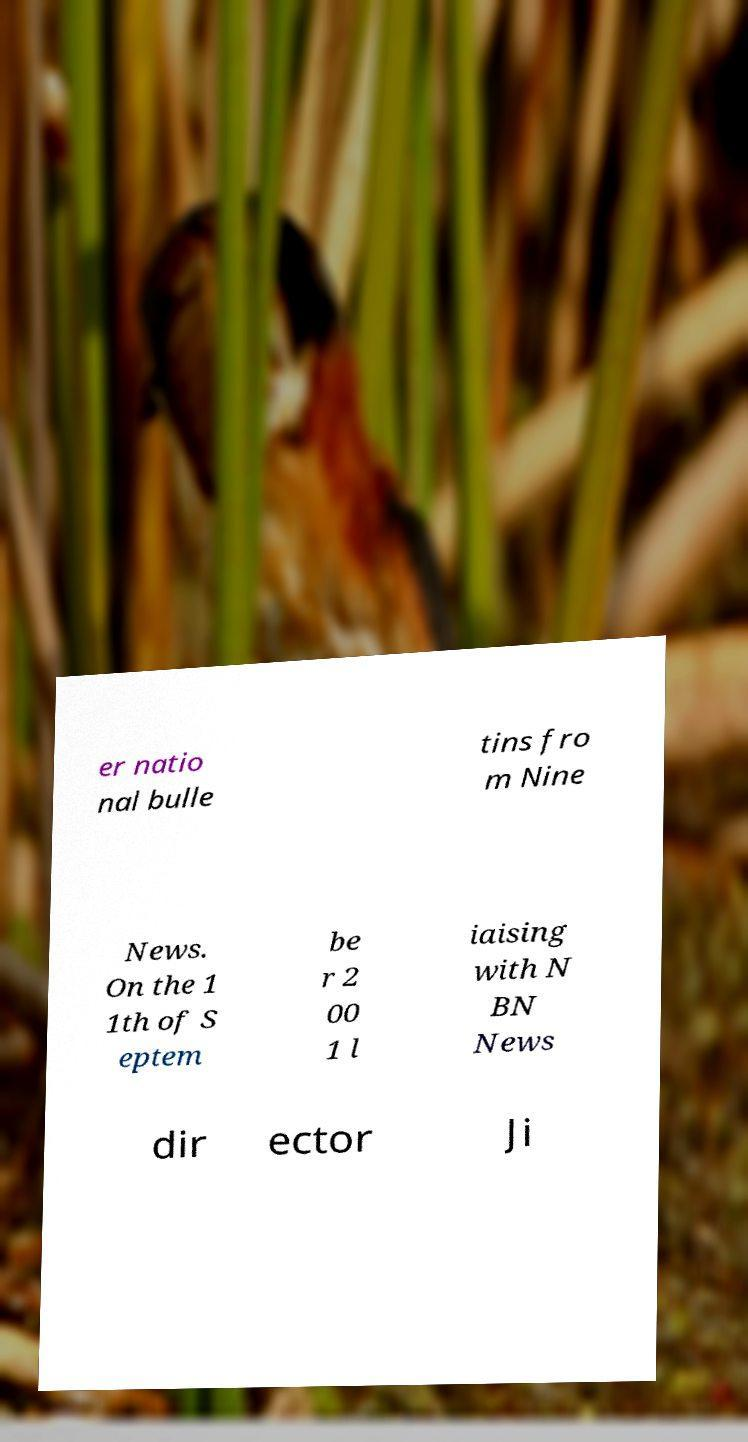There's text embedded in this image that I need extracted. Can you transcribe it verbatim? er natio nal bulle tins fro m Nine News. On the 1 1th of S eptem be r 2 00 1 l iaising with N BN News dir ector Ji 